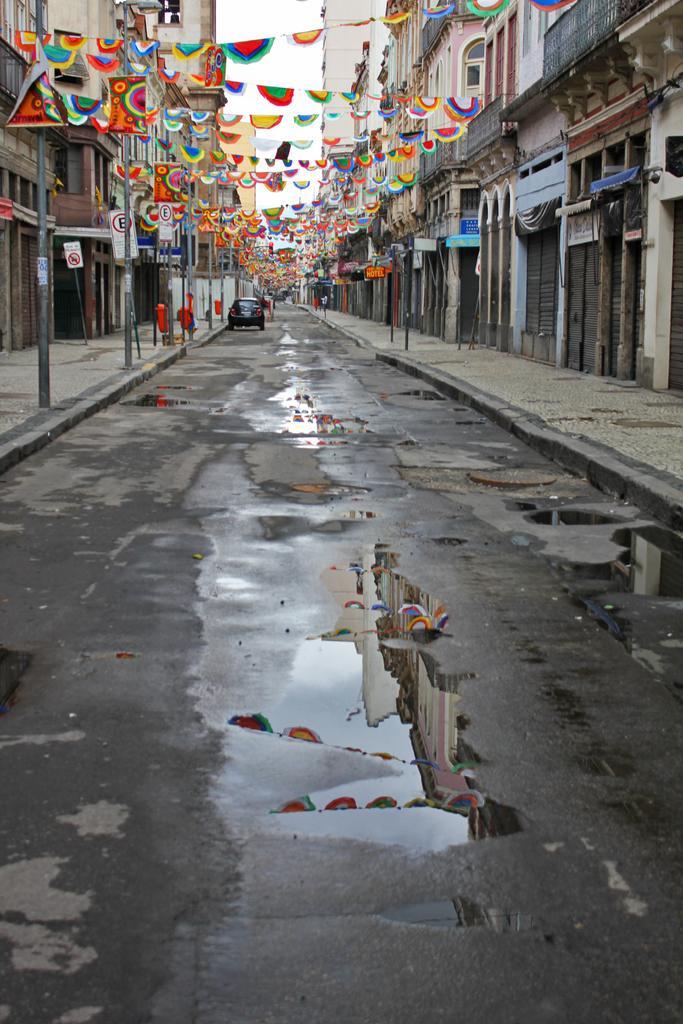Could you give a brief overview of what you see in this image? In the center of the image there is a road and we can see a car on the road. There are poles and buildings. At the top there are flags. In the background there is sky. 